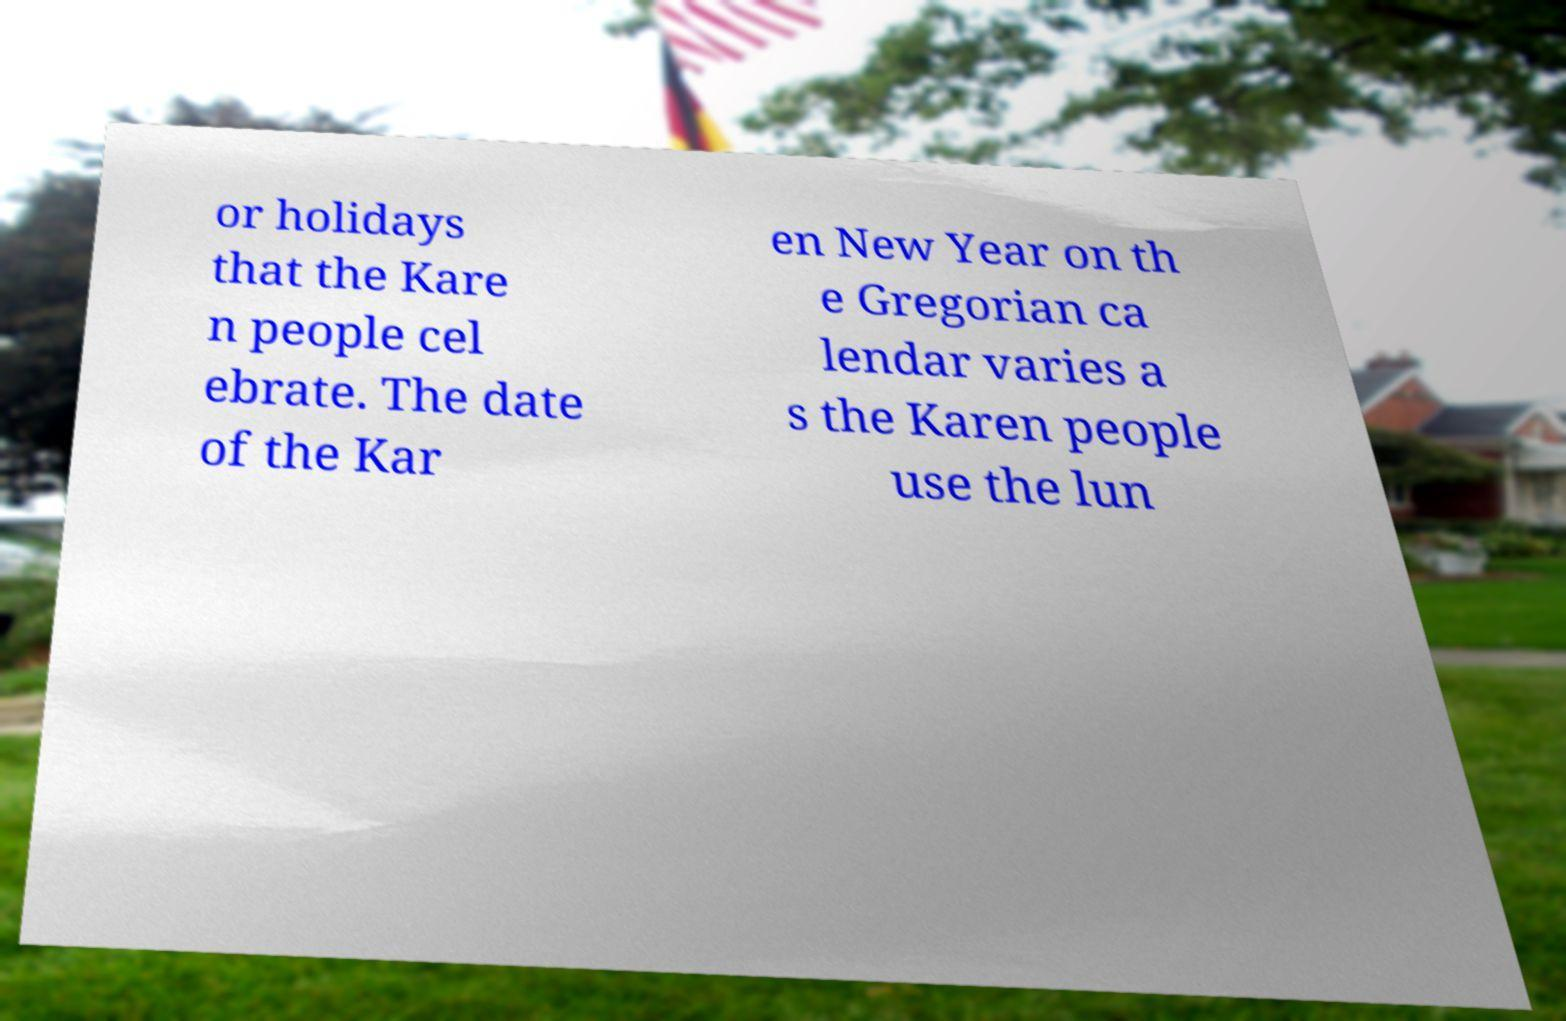There's text embedded in this image that I need extracted. Can you transcribe it verbatim? or holidays that the Kare n people cel ebrate. The date of the Kar en New Year on th e Gregorian ca lendar varies a s the Karen people use the lun 